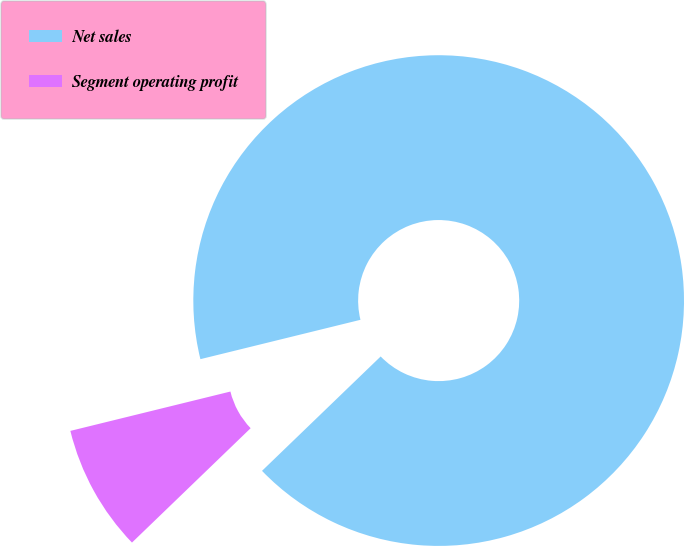<chart> <loc_0><loc_0><loc_500><loc_500><pie_chart><fcel>Net sales<fcel>Segment operating profit<nl><fcel>91.63%<fcel>8.37%<nl></chart> 